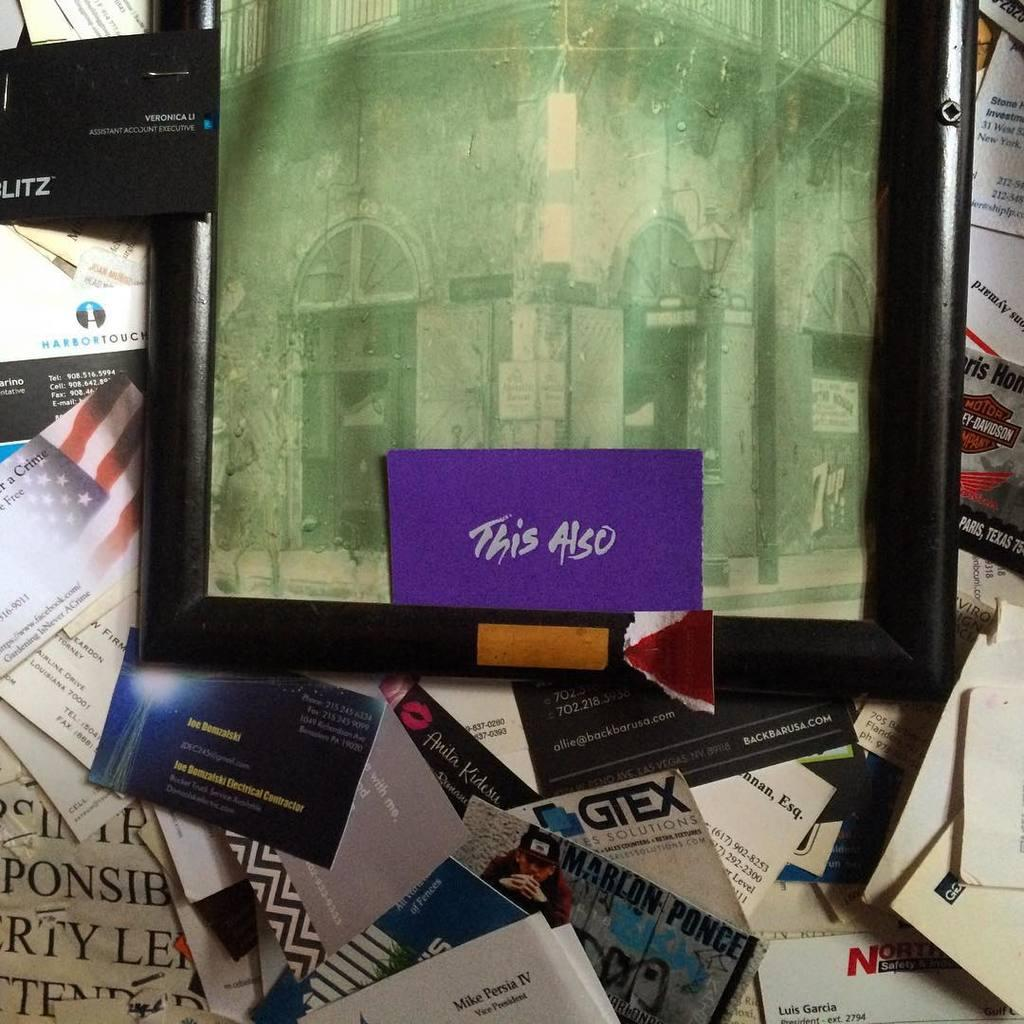<image>
Present a compact description of the photo's key features. Black picture frame with antique greened picture of a corner as the words This Also is printed on bottom of picture on purple card. 